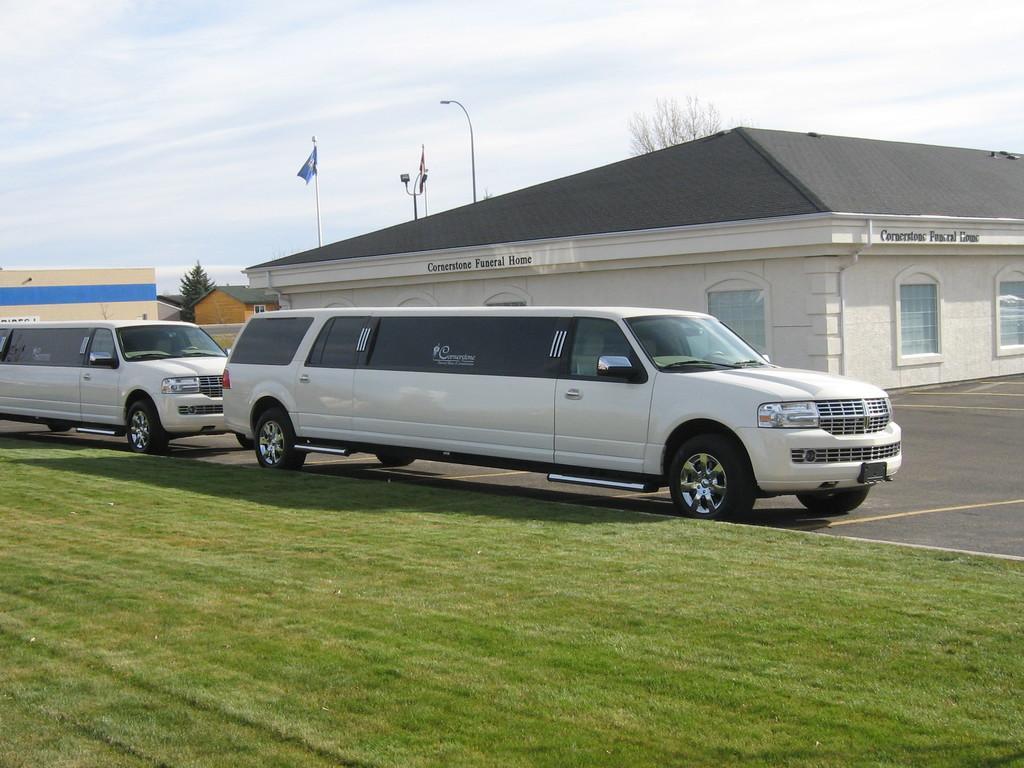How would you summarize this image in a sentence or two? In this picture there are vehicles on the road. At the back there are buildings and trees and street lights and flags. At the top there is sky and there are clouds. At the bottom there is a road and there is grass and there is text on the buildings. 